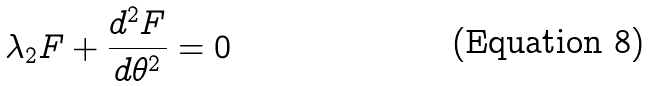<formula> <loc_0><loc_0><loc_500><loc_500>\lambda _ { 2 } F + \frac { d ^ { 2 } F } { d \theta ^ { 2 } } = 0</formula> 